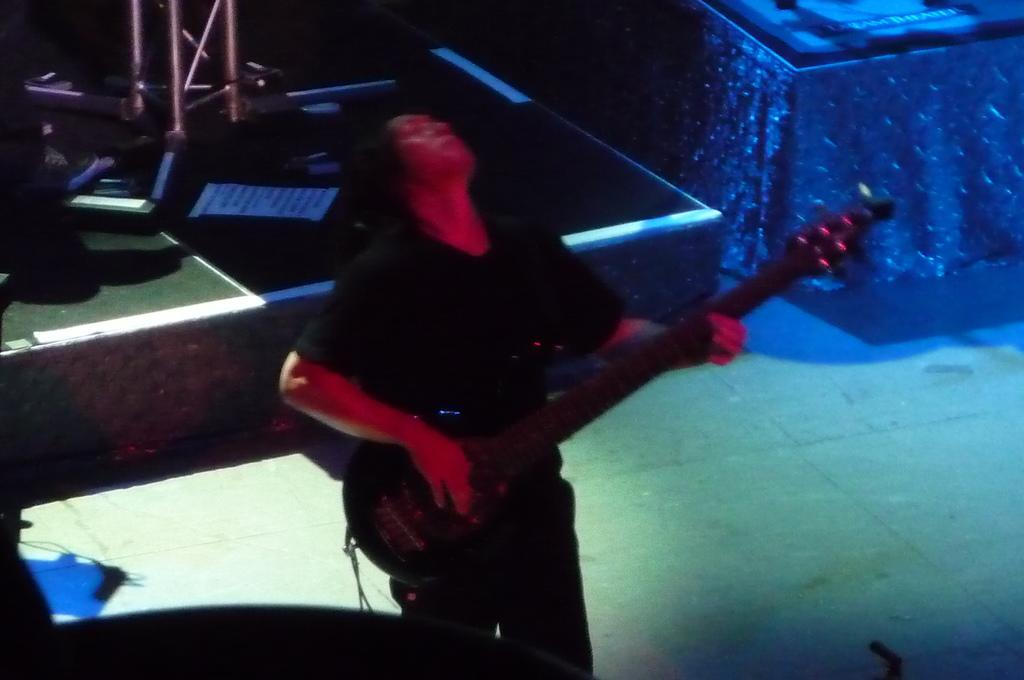What is the person in the image doing? The person is playing the guitar. What is the person wearing in the image? The person is wearing a black dress. What object is the person holding in the image? The person is holding a guitar. What can be seen in the background of the image? There is a stage in the background of the image. What is present on the stage in the image? There are stands on the stage. Can you see a receipt on the stage in the image? There is no receipt present on the stage in the image. What type of honey is being used to tune the guitar in the image? There is no honey present in the image, and the guitar is being played, not tuned. 